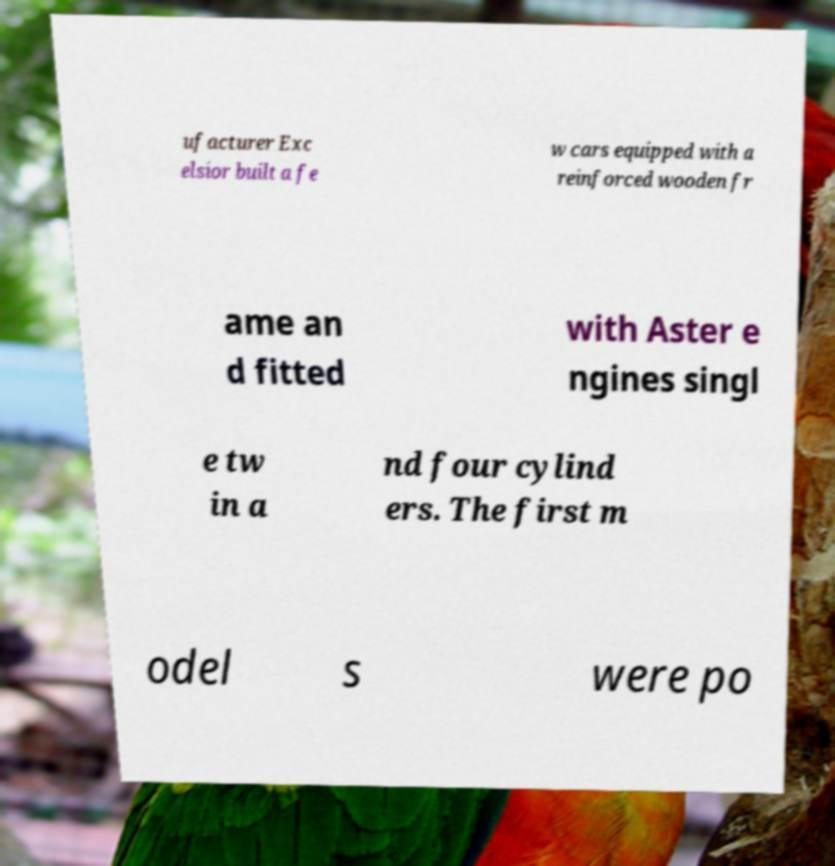Could you assist in decoding the text presented in this image and type it out clearly? ufacturer Exc elsior built a fe w cars equipped with a reinforced wooden fr ame an d fitted with Aster e ngines singl e tw in a nd four cylind ers. The first m odel s were po 